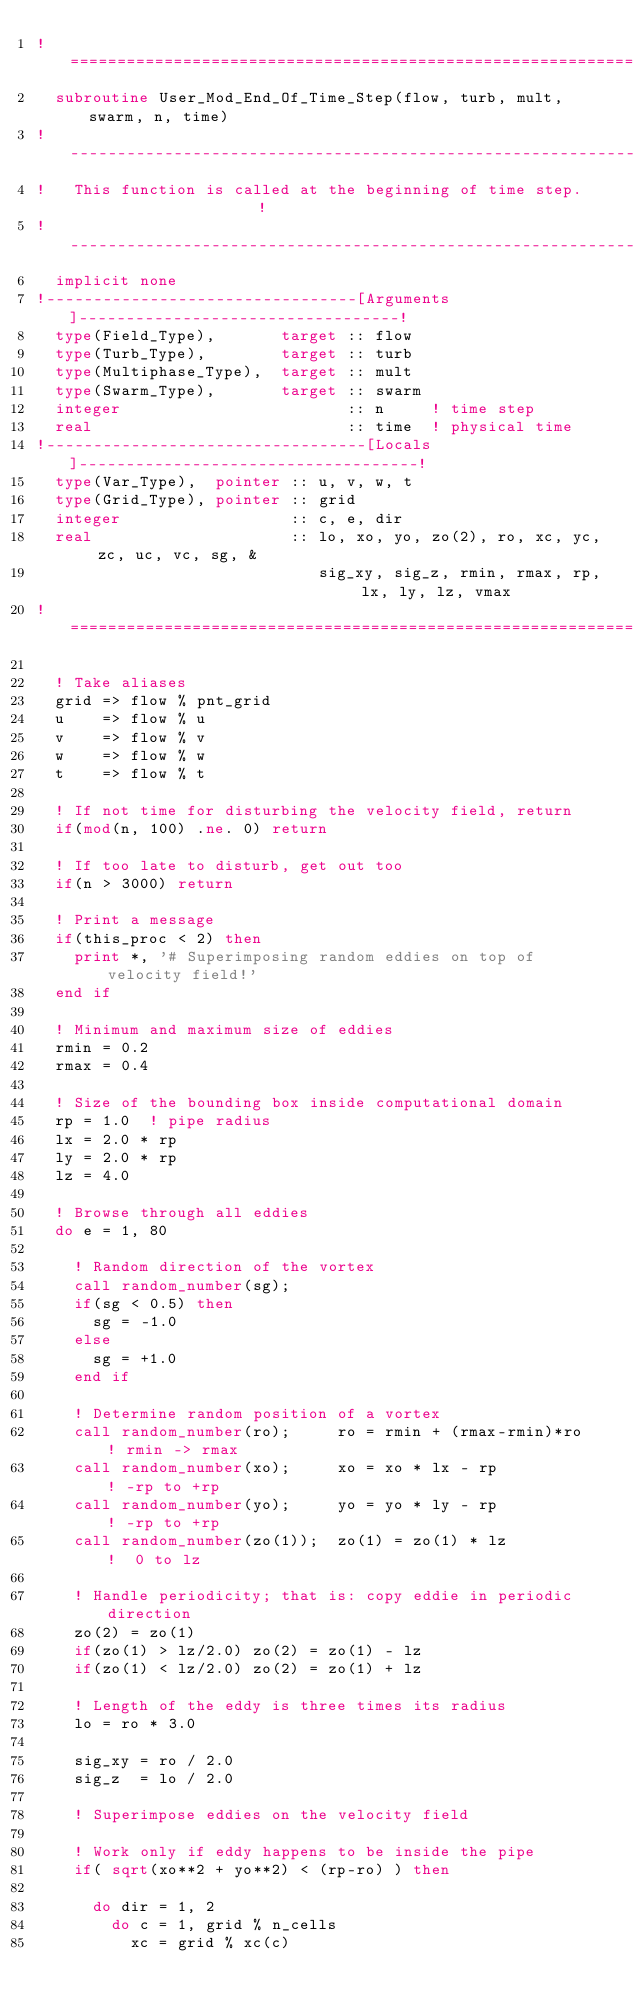<code> <loc_0><loc_0><loc_500><loc_500><_FORTRAN_>!==============================================================================!
  subroutine User_Mod_End_Of_Time_Step(flow, turb, mult, swarm, n, time)
!------------------------------------------------------------------------------!
!   This function is called at the beginning of time step.                     !
!------------------------------------------------------------------------------!
  implicit none
!---------------------------------[Arguments]----------------------------------!
  type(Field_Type),       target :: flow
  type(Turb_Type),        target :: turb
  type(Multiphase_Type),  target :: mult
  type(Swarm_Type),       target :: swarm
  integer                        :: n     ! time step
  real                           :: time  ! physical time
!----------------------------------[Locals]------------------------------------!
  type(Var_Type),  pointer :: u, v, w, t
  type(Grid_Type), pointer :: grid
  integer                  :: c, e, dir
  real                     :: lo, xo, yo, zo(2), ro, xc, yc, zc, uc, vc, sg, &
                              sig_xy, sig_z, rmin, rmax, rp, lx, ly, lz, vmax
!==============================================================================!

  ! Take aliases
  grid => flow % pnt_grid
  u    => flow % u
  v    => flow % v
  w    => flow % w
  t    => flow % t

  ! If not time for disturbing the velocity field, return
  if(mod(n, 100) .ne. 0) return

  ! If too late to disturb, get out too
  if(n > 3000) return

  ! Print a message
  if(this_proc < 2) then
    print *, '# Superimposing random eddies on top of velocity field!'
  end if

  ! Minimum and maximum size of eddies
  rmin = 0.2
  rmax = 0.4

  ! Size of the bounding box inside computational domain
  rp = 1.0  ! pipe radius
  lx = 2.0 * rp
  ly = 2.0 * rp
  lz = 4.0

  ! Browse through all eddies
  do e = 1, 80

    ! Random direction of the vortex
    call random_number(sg);
    if(sg < 0.5) then
      sg = -1.0
    else
      sg = +1.0
    end if

    ! Determine random position of a vortex
    call random_number(ro);     ro = rmin + (rmax-rmin)*ro  ! rmin -> rmax
    call random_number(xo);     xo = xo * lx - rp           ! -rp to +rp
    call random_number(yo);     yo = yo * ly - rp           ! -rp to +rp
    call random_number(zo(1));  zo(1) = zo(1) * lz          !  0 to lz

    ! Handle periodicity; that is: copy eddie in periodic direction
    zo(2) = zo(1)
    if(zo(1) > lz/2.0) zo(2) = zo(1) - lz
    if(zo(1) < lz/2.0) zo(2) = zo(1) + lz

    ! Length of the eddy is three times its radius
    lo = ro * 3.0

    sig_xy = ro / 2.0
    sig_z  = lo / 2.0

    ! Superimpose eddies on the velocity field

    ! Work only if eddy happens to be inside the pipe
    if( sqrt(xo**2 + yo**2) < (rp-ro) ) then

      do dir = 1, 2
        do c = 1, grid % n_cells
          xc = grid % xc(c)</code> 